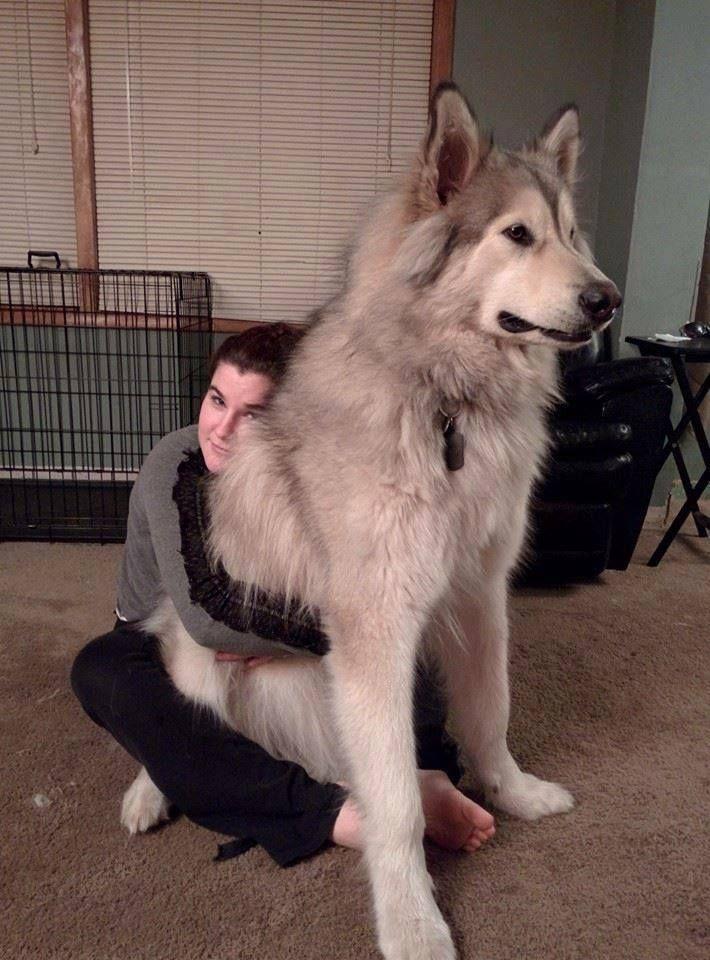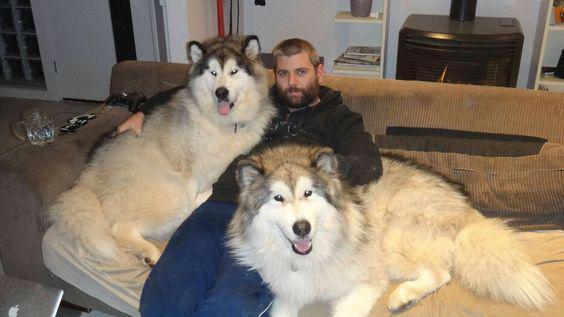The first image is the image on the left, the second image is the image on the right. Evaluate the accuracy of this statement regarding the images: "Each image includes at least one person sitting close to at least one dog in an indoor setting, and the right image shows dog and human on a sofa.". Is it true? Answer yes or no. Yes. The first image is the image on the left, the second image is the image on the right. Examine the images to the left and right. Is the description "There are more dogs in the image on the right." accurate? Answer yes or no. Yes. 